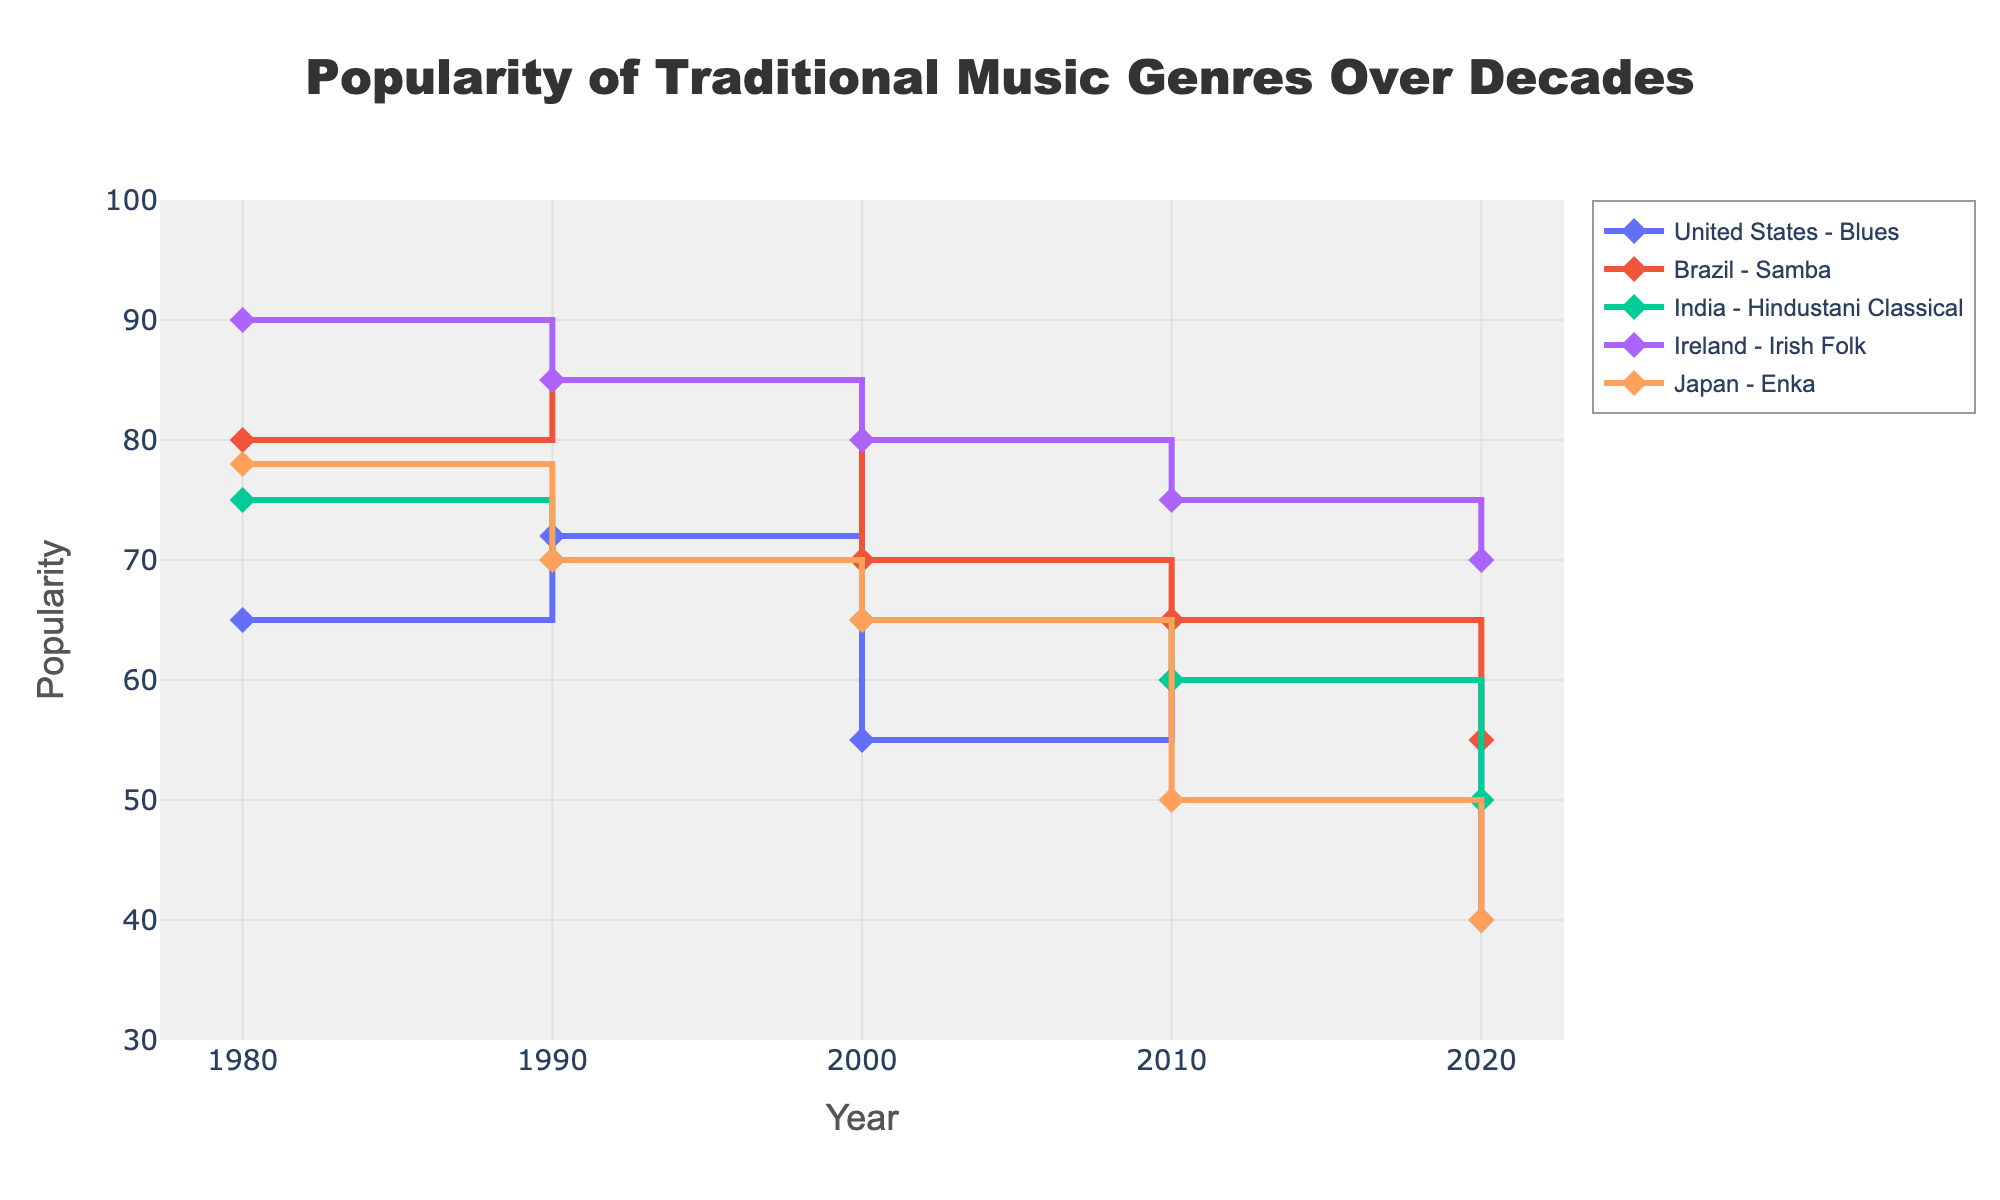What is the title of the plot? The title of the plot is centered at the top, above the actual graph. It appears in a larger, bold font.
Answer: Popularity of Traditional Music Genres Over Decades Which year does the X-axis start and end? The X-axis represents the year and starts at 1980 and ends at 2020.
Answer: 1980 to 2020 What is the highest popularity recorded, and for which genre and country? The highest popularity recorded is 90 for Irish Folk in Ireland in the year 1980. This information can be deduced from observing the endpoints and data points of the lines representing each genre-country pair.
Answer: 90, Irish Folk, Ireland How does the popularity of Blues in the United States change from 1980 to 2020? The popularity of Blues in the United States starts at 65 in 1980, increases to 72 in 1990, decreases to 55 in 2000, rises slightly to 60 in 2010, and finally drops to 40 in 2020.
Answer: It decreases overall Which genre experienced the steepest decline in popularity from 1980 to 2020? Comparing the slopes of the lines for each genre, Enka in Japan shows the steepest decline, going from 78 in 1980 to 40 in 2020.
Answer: Enka in Japan What is the range of popularity for Samba in Brazil? The range can be found by subtracting the lowest value (55 in 2020) from the highest value (85 in 1990).
Answer: 30 What is the overall trend in the popularity of Hindustani Classical in India from 1980 to 2020? The popularity of Hindustani Classical in India consistently decreases from 75 in 1980, to 70 in 1990, to 65 in 2000, to 60 in 2010, and to 50 in 2020.
Answer: Decreasing trend Which country has shown the most consistency in the popularity of its traditional music genre? Irish Folk in Ireland shows the most consistency, with values starting from 90 in 1980 and gradually declining slightly to 70 in 2020, showing less variance compared to other countries and genres.
Answer: Ireland Comparing 1990 and 2020, which genre in Brazil experienced a greater drop in popularity? In 1990, Samba in Brazil had a popularity of 85, which dropped to 55 in 2020, a decrease of 30 units.
Answer: Samba in Brazil How many decades does the plot cover? The plot covers five decades: 1980s, 1990s, 2000s, 2010s, and 2020s.
Answer: Five decades 